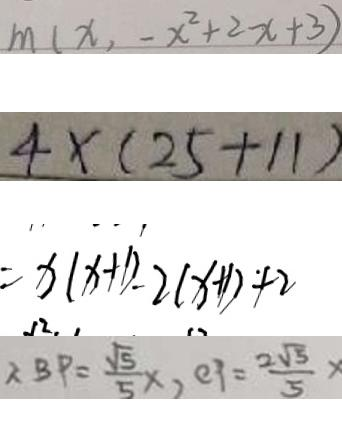<formula> <loc_0><loc_0><loc_500><loc_500>m ( x , - x ^ { 2 } + 2 x + 3 ) 
 4 \times ( 2 5 + 1 1 ) 
 = x ( x + 1 ) - 2 ( x + 1 ) + 2 
 \therefore B P = \frac { \sqrt { 5 } } { 5 } x , e p = \frac { 2 \sqrt { 5 } } { 5 }</formula> 